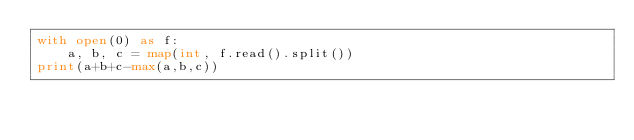<code> <loc_0><loc_0><loc_500><loc_500><_Python_>with open(0) as f:
    a, b, c = map(int, f.read().split())
print(a+b+c-max(a,b,c))</code> 